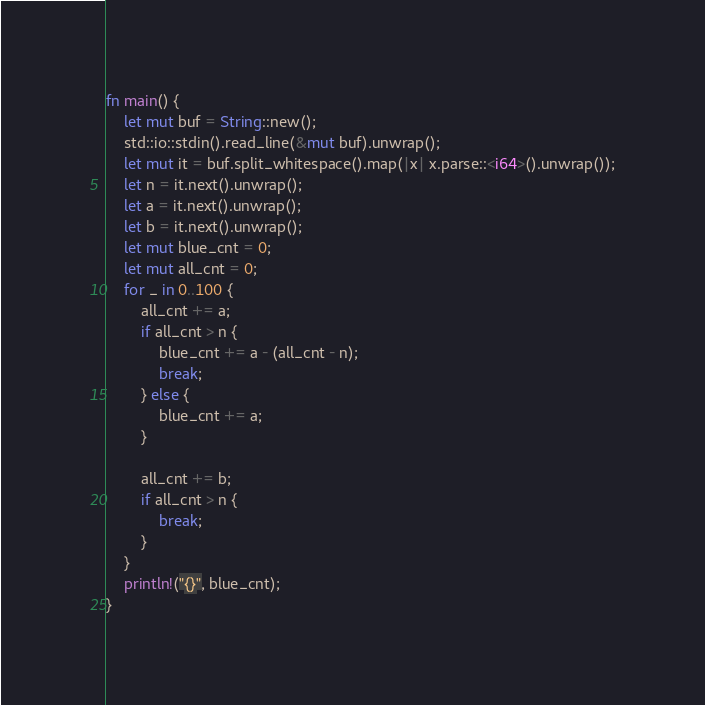Convert code to text. <code><loc_0><loc_0><loc_500><loc_500><_Rust_>fn main() {
    let mut buf = String::new();
    std::io::stdin().read_line(&mut buf).unwrap();
    let mut it = buf.split_whitespace().map(|x| x.parse::<i64>().unwrap());
    let n = it.next().unwrap();
    let a = it.next().unwrap();
    let b = it.next().unwrap();
    let mut blue_cnt = 0;
    let mut all_cnt = 0;
    for _ in 0..100 {
        all_cnt += a;
        if all_cnt > n {
            blue_cnt += a - (all_cnt - n);
            break;
        } else {
            blue_cnt += a;
        }

        all_cnt += b;
        if all_cnt > n {
            break;
        }
    }
    println!("{}", blue_cnt);
}
</code> 